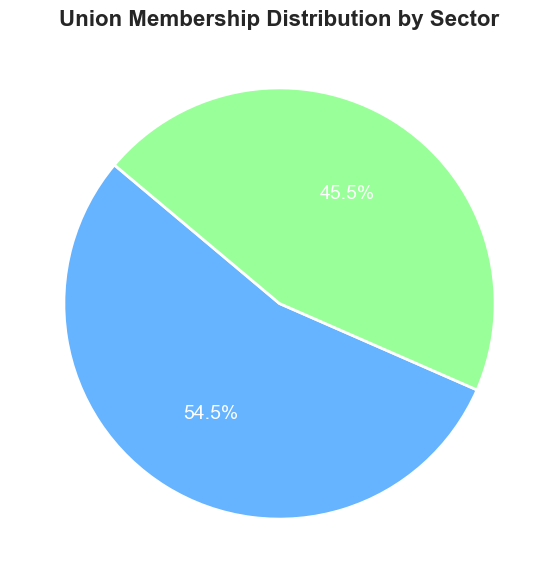What's the percentage of union members in the private sector? According to the pie chart, the private sector's segment shows the percent of union membership, which can be directly read off the chart.
Answer: 45.5% Which sector has a larger share of union membership? By comparing the slices of the pie chart, the public sector occupies a larger segment compared to the private sector.
Answer: Public sector What's the difference in the number of union members between the public and private sectors? The public sector has 7,200,000 members and the private sector has 6,000,000. The difference is calculated by subtracting the private sector's membership from the public sector's membership: 7,200,000 - 6,000,000 = 1,200,000.
Answer: 1,200,000 If the total number of union members is 13,200,000, what's the percentage of public sector union members? The public sector has 7,200,000 members out of a total of 13,200,000. To calculate the percentage: (7,200,000 / 13,200,000) * 100 ≈ 54.5%.
Answer: 54.5% Which color represents the private sector in the pie chart? The pie chart uses different colors for each sector, and from the description, the private sector is represented by a lighter green shade.
Answer: Green What is the total membership of both sectors combined? Add the memberships of both sectors: 7,200,000 (public) + 6,000,000 (private) = 13,200,000.
Answer: 13,200,000 What is the width of the border around the pie chart pieces? Visual inspection of the pie chart shows a white border around each slice with a consistent width.
Answer: 2 units How much wider is the public sector's slice compared to the private sector's slice? The public sector's slice is about 54.5%, and the private sector's slice is about 45.5%. This gives a difference of 54.5% - 45.5% = 9%.
Answer: 9% What is the title of the pie chart? The title is displayed at the top of the pie chart, indicating the context or purpose of the chart.
Answer: Union Membership Distribution by Sector What is the font size used for the text in the pie chart? The description mentions that the text font size used in the pie chart is set at 14 for both labels and percentages.
Answer: 14 